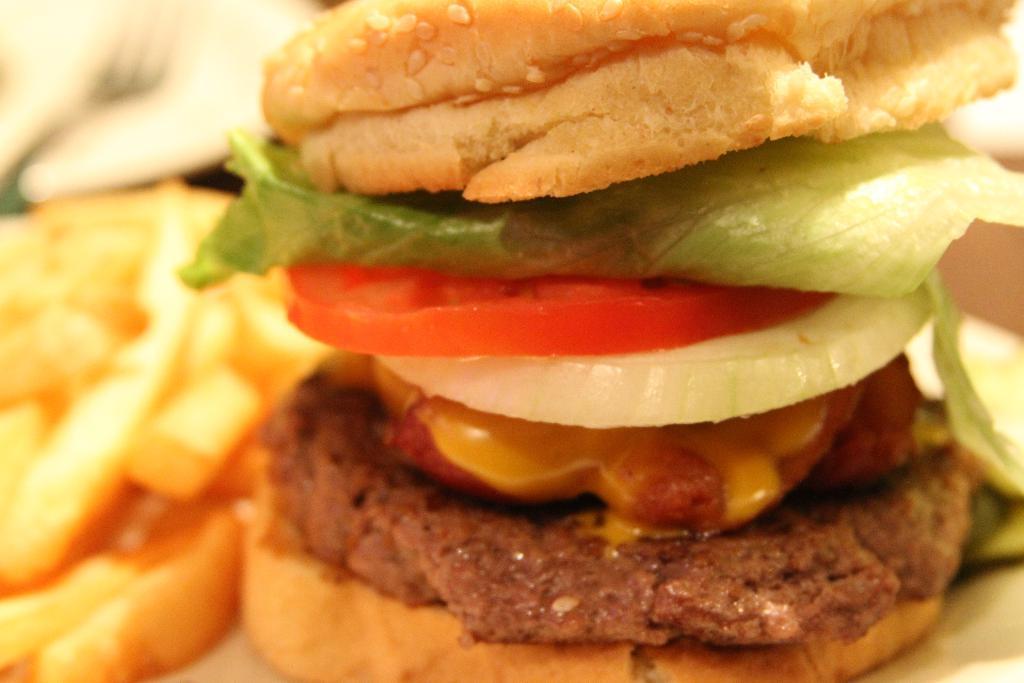Please provide a concise description of this image. In this image we can see there are some food items and there is the blur background. 